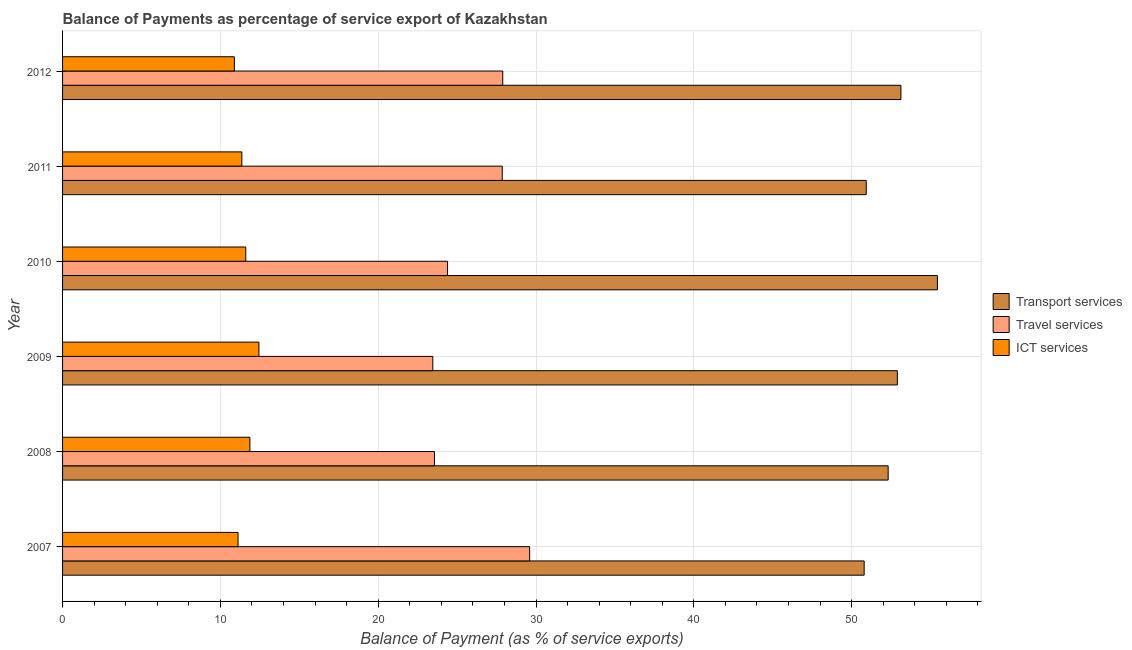Are the number of bars on each tick of the Y-axis equal?
Provide a short and direct response. Yes. How many bars are there on the 1st tick from the top?
Keep it short and to the point. 3. How many bars are there on the 2nd tick from the bottom?
Your response must be concise. 3. In how many cases, is the number of bars for a given year not equal to the number of legend labels?
Your answer should be very brief. 0. What is the balance of payment of ict services in 2008?
Your response must be concise. 11.87. Across all years, what is the maximum balance of payment of transport services?
Give a very brief answer. 55.44. Across all years, what is the minimum balance of payment of ict services?
Provide a short and direct response. 10.89. In which year was the balance of payment of travel services minimum?
Your response must be concise. 2009. What is the total balance of payment of ict services in the graph?
Your answer should be compact. 69.29. What is the difference between the balance of payment of travel services in 2007 and that in 2010?
Keep it short and to the point. 5.2. What is the difference between the balance of payment of ict services in 2007 and the balance of payment of travel services in 2011?
Provide a short and direct response. -16.74. What is the average balance of payment of transport services per year?
Your response must be concise. 52.58. In the year 2012, what is the difference between the balance of payment of travel services and balance of payment of ict services?
Provide a short and direct response. 17.01. Is the difference between the balance of payment of travel services in 2010 and 2012 greater than the difference between the balance of payment of transport services in 2010 and 2012?
Make the answer very short. No. What is the difference between the highest and the second highest balance of payment of travel services?
Offer a very short reply. 1.7. What is the difference between the highest and the lowest balance of payment of transport services?
Give a very brief answer. 4.64. In how many years, is the balance of payment of ict services greater than the average balance of payment of ict services taken over all years?
Offer a very short reply. 3. What does the 2nd bar from the top in 2008 represents?
Provide a short and direct response. Travel services. What does the 1st bar from the bottom in 2007 represents?
Offer a very short reply. Transport services. Are all the bars in the graph horizontal?
Ensure brevity in your answer.  Yes. Are the values on the major ticks of X-axis written in scientific E-notation?
Provide a succinct answer. No. Where does the legend appear in the graph?
Offer a terse response. Center right. How many legend labels are there?
Your response must be concise. 3. How are the legend labels stacked?
Keep it short and to the point. Vertical. What is the title of the graph?
Provide a short and direct response. Balance of Payments as percentage of service export of Kazakhstan. What is the label or title of the X-axis?
Offer a very short reply. Balance of Payment (as % of service exports). What is the label or title of the Y-axis?
Make the answer very short. Year. What is the Balance of Payment (as % of service exports) of Transport services in 2007?
Keep it short and to the point. 50.8. What is the Balance of Payment (as % of service exports) of Travel services in 2007?
Keep it short and to the point. 29.6. What is the Balance of Payment (as % of service exports) of ICT services in 2007?
Offer a very short reply. 11.12. What is the Balance of Payment (as % of service exports) in Transport services in 2008?
Make the answer very short. 52.32. What is the Balance of Payment (as % of service exports) in Travel services in 2008?
Your answer should be very brief. 23.57. What is the Balance of Payment (as % of service exports) in ICT services in 2008?
Offer a terse response. 11.87. What is the Balance of Payment (as % of service exports) in Transport services in 2009?
Provide a succinct answer. 52.9. What is the Balance of Payment (as % of service exports) of Travel services in 2009?
Your answer should be very brief. 23.46. What is the Balance of Payment (as % of service exports) of ICT services in 2009?
Make the answer very short. 12.44. What is the Balance of Payment (as % of service exports) in Transport services in 2010?
Ensure brevity in your answer.  55.44. What is the Balance of Payment (as % of service exports) in Travel services in 2010?
Offer a terse response. 24.39. What is the Balance of Payment (as % of service exports) of ICT services in 2010?
Your response must be concise. 11.61. What is the Balance of Payment (as % of service exports) in Transport services in 2011?
Provide a short and direct response. 50.93. What is the Balance of Payment (as % of service exports) in Travel services in 2011?
Provide a short and direct response. 27.86. What is the Balance of Payment (as % of service exports) in ICT services in 2011?
Provide a succinct answer. 11.36. What is the Balance of Payment (as % of service exports) of Transport services in 2012?
Provide a short and direct response. 53.12. What is the Balance of Payment (as % of service exports) of Travel services in 2012?
Provide a succinct answer. 27.89. What is the Balance of Payment (as % of service exports) of ICT services in 2012?
Offer a terse response. 10.89. Across all years, what is the maximum Balance of Payment (as % of service exports) of Transport services?
Give a very brief answer. 55.44. Across all years, what is the maximum Balance of Payment (as % of service exports) of Travel services?
Your answer should be compact. 29.6. Across all years, what is the maximum Balance of Payment (as % of service exports) in ICT services?
Your answer should be very brief. 12.44. Across all years, what is the minimum Balance of Payment (as % of service exports) in Transport services?
Make the answer very short. 50.8. Across all years, what is the minimum Balance of Payment (as % of service exports) in Travel services?
Your answer should be compact. 23.46. Across all years, what is the minimum Balance of Payment (as % of service exports) in ICT services?
Your answer should be compact. 10.89. What is the total Balance of Payment (as % of service exports) in Transport services in the graph?
Provide a short and direct response. 315.49. What is the total Balance of Payment (as % of service exports) in Travel services in the graph?
Provide a short and direct response. 156.77. What is the total Balance of Payment (as % of service exports) in ICT services in the graph?
Give a very brief answer. 69.29. What is the difference between the Balance of Payment (as % of service exports) of Transport services in 2007 and that in 2008?
Your response must be concise. -1.52. What is the difference between the Balance of Payment (as % of service exports) in Travel services in 2007 and that in 2008?
Give a very brief answer. 6.03. What is the difference between the Balance of Payment (as % of service exports) in ICT services in 2007 and that in 2008?
Your response must be concise. -0.75. What is the difference between the Balance of Payment (as % of service exports) of Transport services in 2007 and that in 2009?
Make the answer very short. -2.1. What is the difference between the Balance of Payment (as % of service exports) of Travel services in 2007 and that in 2009?
Provide a succinct answer. 6.14. What is the difference between the Balance of Payment (as % of service exports) in ICT services in 2007 and that in 2009?
Keep it short and to the point. -1.32. What is the difference between the Balance of Payment (as % of service exports) of Transport services in 2007 and that in 2010?
Your answer should be compact. -4.64. What is the difference between the Balance of Payment (as % of service exports) of Travel services in 2007 and that in 2010?
Offer a terse response. 5.2. What is the difference between the Balance of Payment (as % of service exports) in ICT services in 2007 and that in 2010?
Make the answer very short. -0.49. What is the difference between the Balance of Payment (as % of service exports) of Transport services in 2007 and that in 2011?
Give a very brief answer. -0.13. What is the difference between the Balance of Payment (as % of service exports) in Travel services in 2007 and that in 2011?
Make the answer very short. 1.74. What is the difference between the Balance of Payment (as % of service exports) of ICT services in 2007 and that in 2011?
Ensure brevity in your answer.  -0.24. What is the difference between the Balance of Payment (as % of service exports) in Transport services in 2007 and that in 2012?
Ensure brevity in your answer.  -2.33. What is the difference between the Balance of Payment (as % of service exports) in Travel services in 2007 and that in 2012?
Give a very brief answer. 1.7. What is the difference between the Balance of Payment (as % of service exports) of ICT services in 2007 and that in 2012?
Keep it short and to the point. 0.23. What is the difference between the Balance of Payment (as % of service exports) of Transport services in 2008 and that in 2009?
Provide a short and direct response. -0.58. What is the difference between the Balance of Payment (as % of service exports) of Travel services in 2008 and that in 2009?
Your answer should be compact. 0.11. What is the difference between the Balance of Payment (as % of service exports) of ICT services in 2008 and that in 2009?
Give a very brief answer. -0.57. What is the difference between the Balance of Payment (as % of service exports) of Transport services in 2008 and that in 2010?
Your answer should be very brief. -3.12. What is the difference between the Balance of Payment (as % of service exports) in Travel services in 2008 and that in 2010?
Give a very brief answer. -0.83. What is the difference between the Balance of Payment (as % of service exports) of ICT services in 2008 and that in 2010?
Your response must be concise. 0.26. What is the difference between the Balance of Payment (as % of service exports) of Transport services in 2008 and that in 2011?
Offer a terse response. 1.39. What is the difference between the Balance of Payment (as % of service exports) of Travel services in 2008 and that in 2011?
Provide a short and direct response. -4.29. What is the difference between the Balance of Payment (as % of service exports) of ICT services in 2008 and that in 2011?
Your response must be concise. 0.51. What is the difference between the Balance of Payment (as % of service exports) of Transport services in 2008 and that in 2012?
Make the answer very short. -0.81. What is the difference between the Balance of Payment (as % of service exports) of Travel services in 2008 and that in 2012?
Your answer should be very brief. -4.33. What is the difference between the Balance of Payment (as % of service exports) in ICT services in 2008 and that in 2012?
Offer a very short reply. 0.98. What is the difference between the Balance of Payment (as % of service exports) in Transport services in 2009 and that in 2010?
Your answer should be very brief. -2.54. What is the difference between the Balance of Payment (as % of service exports) in Travel services in 2009 and that in 2010?
Your response must be concise. -0.93. What is the difference between the Balance of Payment (as % of service exports) in ICT services in 2009 and that in 2010?
Keep it short and to the point. 0.83. What is the difference between the Balance of Payment (as % of service exports) of Transport services in 2009 and that in 2011?
Give a very brief answer. 1.97. What is the difference between the Balance of Payment (as % of service exports) of Travel services in 2009 and that in 2011?
Give a very brief answer. -4.4. What is the difference between the Balance of Payment (as % of service exports) of ICT services in 2009 and that in 2011?
Give a very brief answer. 1.08. What is the difference between the Balance of Payment (as % of service exports) in Transport services in 2009 and that in 2012?
Make the answer very short. -0.23. What is the difference between the Balance of Payment (as % of service exports) in Travel services in 2009 and that in 2012?
Provide a short and direct response. -4.43. What is the difference between the Balance of Payment (as % of service exports) of ICT services in 2009 and that in 2012?
Your answer should be compact. 1.56. What is the difference between the Balance of Payment (as % of service exports) of Transport services in 2010 and that in 2011?
Provide a succinct answer. 4.51. What is the difference between the Balance of Payment (as % of service exports) of Travel services in 2010 and that in 2011?
Provide a succinct answer. -3.47. What is the difference between the Balance of Payment (as % of service exports) in ICT services in 2010 and that in 2011?
Your answer should be very brief. 0.25. What is the difference between the Balance of Payment (as % of service exports) of Transport services in 2010 and that in 2012?
Your answer should be compact. 2.31. What is the difference between the Balance of Payment (as % of service exports) in Travel services in 2010 and that in 2012?
Provide a short and direct response. -3.5. What is the difference between the Balance of Payment (as % of service exports) of ICT services in 2010 and that in 2012?
Ensure brevity in your answer.  0.72. What is the difference between the Balance of Payment (as % of service exports) of Transport services in 2011 and that in 2012?
Give a very brief answer. -2.2. What is the difference between the Balance of Payment (as % of service exports) in Travel services in 2011 and that in 2012?
Your answer should be very brief. -0.03. What is the difference between the Balance of Payment (as % of service exports) in ICT services in 2011 and that in 2012?
Your answer should be very brief. 0.47. What is the difference between the Balance of Payment (as % of service exports) in Transport services in 2007 and the Balance of Payment (as % of service exports) in Travel services in 2008?
Keep it short and to the point. 27.23. What is the difference between the Balance of Payment (as % of service exports) of Transport services in 2007 and the Balance of Payment (as % of service exports) of ICT services in 2008?
Offer a terse response. 38.93. What is the difference between the Balance of Payment (as % of service exports) in Travel services in 2007 and the Balance of Payment (as % of service exports) in ICT services in 2008?
Give a very brief answer. 17.73. What is the difference between the Balance of Payment (as % of service exports) in Transport services in 2007 and the Balance of Payment (as % of service exports) in Travel services in 2009?
Your answer should be compact. 27.33. What is the difference between the Balance of Payment (as % of service exports) of Transport services in 2007 and the Balance of Payment (as % of service exports) of ICT services in 2009?
Provide a short and direct response. 38.35. What is the difference between the Balance of Payment (as % of service exports) of Travel services in 2007 and the Balance of Payment (as % of service exports) of ICT services in 2009?
Give a very brief answer. 17.15. What is the difference between the Balance of Payment (as % of service exports) of Transport services in 2007 and the Balance of Payment (as % of service exports) of Travel services in 2010?
Make the answer very short. 26.4. What is the difference between the Balance of Payment (as % of service exports) in Transport services in 2007 and the Balance of Payment (as % of service exports) in ICT services in 2010?
Your answer should be compact. 39.19. What is the difference between the Balance of Payment (as % of service exports) in Travel services in 2007 and the Balance of Payment (as % of service exports) in ICT services in 2010?
Offer a terse response. 17.99. What is the difference between the Balance of Payment (as % of service exports) in Transport services in 2007 and the Balance of Payment (as % of service exports) in Travel services in 2011?
Offer a very short reply. 22.93. What is the difference between the Balance of Payment (as % of service exports) of Transport services in 2007 and the Balance of Payment (as % of service exports) of ICT services in 2011?
Give a very brief answer. 39.43. What is the difference between the Balance of Payment (as % of service exports) of Travel services in 2007 and the Balance of Payment (as % of service exports) of ICT services in 2011?
Provide a succinct answer. 18.24. What is the difference between the Balance of Payment (as % of service exports) in Transport services in 2007 and the Balance of Payment (as % of service exports) in Travel services in 2012?
Your answer should be very brief. 22.9. What is the difference between the Balance of Payment (as % of service exports) in Transport services in 2007 and the Balance of Payment (as % of service exports) in ICT services in 2012?
Your answer should be compact. 39.91. What is the difference between the Balance of Payment (as % of service exports) of Travel services in 2007 and the Balance of Payment (as % of service exports) of ICT services in 2012?
Ensure brevity in your answer.  18.71. What is the difference between the Balance of Payment (as % of service exports) in Transport services in 2008 and the Balance of Payment (as % of service exports) in Travel services in 2009?
Provide a short and direct response. 28.85. What is the difference between the Balance of Payment (as % of service exports) of Transport services in 2008 and the Balance of Payment (as % of service exports) of ICT services in 2009?
Keep it short and to the point. 39.87. What is the difference between the Balance of Payment (as % of service exports) of Travel services in 2008 and the Balance of Payment (as % of service exports) of ICT services in 2009?
Give a very brief answer. 11.12. What is the difference between the Balance of Payment (as % of service exports) in Transport services in 2008 and the Balance of Payment (as % of service exports) in Travel services in 2010?
Offer a terse response. 27.92. What is the difference between the Balance of Payment (as % of service exports) in Transport services in 2008 and the Balance of Payment (as % of service exports) in ICT services in 2010?
Your response must be concise. 40.71. What is the difference between the Balance of Payment (as % of service exports) of Travel services in 2008 and the Balance of Payment (as % of service exports) of ICT services in 2010?
Your answer should be very brief. 11.96. What is the difference between the Balance of Payment (as % of service exports) in Transport services in 2008 and the Balance of Payment (as % of service exports) in Travel services in 2011?
Provide a succinct answer. 24.45. What is the difference between the Balance of Payment (as % of service exports) of Transport services in 2008 and the Balance of Payment (as % of service exports) of ICT services in 2011?
Make the answer very short. 40.95. What is the difference between the Balance of Payment (as % of service exports) of Travel services in 2008 and the Balance of Payment (as % of service exports) of ICT services in 2011?
Offer a terse response. 12.21. What is the difference between the Balance of Payment (as % of service exports) in Transport services in 2008 and the Balance of Payment (as % of service exports) in Travel services in 2012?
Your answer should be very brief. 24.42. What is the difference between the Balance of Payment (as % of service exports) of Transport services in 2008 and the Balance of Payment (as % of service exports) of ICT services in 2012?
Keep it short and to the point. 41.43. What is the difference between the Balance of Payment (as % of service exports) of Travel services in 2008 and the Balance of Payment (as % of service exports) of ICT services in 2012?
Your answer should be compact. 12.68. What is the difference between the Balance of Payment (as % of service exports) in Transport services in 2009 and the Balance of Payment (as % of service exports) in Travel services in 2010?
Your answer should be very brief. 28.5. What is the difference between the Balance of Payment (as % of service exports) in Transport services in 2009 and the Balance of Payment (as % of service exports) in ICT services in 2010?
Provide a succinct answer. 41.29. What is the difference between the Balance of Payment (as % of service exports) in Travel services in 2009 and the Balance of Payment (as % of service exports) in ICT services in 2010?
Give a very brief answer. 11.85. What is the difference between the Balance of Payment (as % of service exports) of Transport services in 2009 and the Balance of Payment (as % of service exports) of Travel services in 2011?
Ensure brevity in your answer.  25.04. What is the difference between the Balance of Payment (as % of service exports) of Transport services in 2009 and the Balance of Payment (as % of service exports) of ICT services in 2011?
Keep it short and to the point. 41.54. What is the difference between the Balance of Payment (as % of service exports) of Travel services in 2009 and the Balance of Payment (as % of service exports) of ICT services in 2011?
Provide a succinct answer. 12.1. What is the difference between the Balance of Payment (as % of service exports) of Transport services in 2009 and the Balance of Payment (as % of service exports) of Travel services in 2012?
Your response must be concise. 25. What is the difference between the Balance of Payment (as % of service exports) of Transport services in 2009 and the Balance of Payment (as % of service exports) of ICT services in 2012?
Provide a succinct answer. 42.01. What is the difference between the Balance of Payment (as % of service exports) in Travel services in 2009 and the Balance of Payment (as % of service exports) in ICT services in 2012?
Offer a very short reply. 12.57. What is the difference between the Balance of Payment (as % of service exports) of Transport services in 2010 and the Balance of Payment (as % of service exports) of Travel services in 2011?
Ensure brevity in your answer.  27.58. What is the difference between the Balance of Payment (as % of service exports) of Transport services in 2010 and the Balance of Payment (as % of service exports) of ICT services in 2011?
Offer a terse response. 44.08. What is the difference between the Balance of Payment (as % of service exports) in Travel services in 2010 and the Balance of Payment (as % of service exports) in ICT services in 2011?
Your answer should be compact. 13.03. What is the difference between the Balance of Payment (as % of service exports) of Transport services in 2010 and the Balance of Payment (as % of service exports) of Travel services in 2012?
Make the answer very short. 27.54. What is the difference between the Balance of Payment (as % of service exports) of Transport services in 2010 and the Balance of Payment (as % of service exports) of ICT services in 2012?
Offer a terse response. 44.55. What is the difference between the Balance of Payment (as % of service exports) in Travel services in 2010 and the Balance of Payment (as % of service exports) in ICT services in 2012?
Provide a short and direct response. 13.51. What is the difference between the Balance of Payment (as % of service exports) in Transport services in 2011 and the Balance of Payment (as % of service exports) in Travel services in 2012?
Ensure brevity in your answer.  23.03. What is the difference between the Balance of Payment (as % of service exports) of Transport services in 2011 and the Balance of Payment (as % of service exports) of ICT services in 2012?
Make the answer very short. 40.04. What is the difference between the Balance of Payment (as % of service exports) of Travel services in 2011 and the Balance of Payment (as % of service exports) of ICT services in 2012?
Make the answer very short. 16.97. What is the average Balance of Payment (as % of service exports) of Transport services per year?
Keep it short and to the point. 52.58. What is the average Balance of Payment (as % of service exports) of Travel services per year?
Ensure brevity in your answer.  26.13. What is the average Balance of Payment (as % of service exports) of ICT services per year?
Keep it short and to the point. 11.55. In the year 2007, what is the difference between the Balance of Payment (as % of service exports) of Transport services and Balance of Payment (as % of service exports) of Travel services?
Keep it short and to the point. 21.2. In the year 2007, what is the difference between the Balance of Payment (as % of service exports) in Transport services and Balance of Payment (as % of service exports) in ICT services?
Your answer should be very brief. 39.68. In the year 2007, what is the difference between the Balance of Payment (as % of service exports) of Travel services and Balance of Payment (as % of service exports) of ICT services?
Provide a short and direct response. 18.48. In the year 2008, what is the difference between the Balance of Payment (as % of service exports) of Transport services and Balance of Payment (as % of service exports) of Travel services?
Provide a succinct answer. 28.75. In the year 2008, what is the difference between the Balance of Payment (as % of service exports) of Transport services and Balance of Payment (as % of service exports) of ICT services?
Ensure brevity in your answer.  40.45. In the year 2008, what is the difference between the Balance of Payment (as % of service exports) in Travel services and Balance of Payment (as % of service exports) in ICT services?
Ensure brevity in your answer.  11.7. In the year 2009, what is the difference between the Balance of Payment (as % of service exports) of Transport services and Balance of Payment (as % of service exports) of Travel services?
Offer a terse response. 29.44. In the year 2009, what is the difference between the Balance of Payment (as % of service exports) of Transport services and Balance of Payment (as % of service exports) of ICT services?
Provide a succinct answer. 40.45. In the year 2009, what is the difference between the Balance of Payment (as % of service exports) of Travel services and Balance of Payment (as % of service exports) of ICT services?
Provide a short and direct response. 11.02. In the year 2010, what is the difference between the Balance of Payment (as % of service exports) of Transport services and Balance of Payment (as % of service exports) of Travel services?
Give a very brief answer. 31.04. In the year 2010, what is the difference between the Balance of Payment (as % of service exports) in Transport services and Balance of Payment (as % of service exports) in ICT services?
Ensure brevity in your answer.  43.83. In the year 2010, what is the difference between the Balance of Payment (as % of service exports) of Travel services and Balance of Payment (as % of service exports) of ICT services?
Make the answer very short. 12.79. In the year 2011, what is the difference between the Balance of Payment (as % of service exports) of Transport services and Balance of Payment (as % of service exports) of Travel services?
Provide a short and direct response. 23.07. In the year 2011, what is the difference between the Balance of Payment (as % of service exports) of Transport services and Balance of Payment (as % of service exports) of ICT services?
Keep it short and to the point. 39.57. In the year 2011, what is the difference between the Balance of Payment (as % of service exports) of Travel services and Balance of Payment (as % of service exports) of ICT services?
Your response must be concise. 16.5. In the year 2012, what is the difference between the Balance of Payment (as % of service exports) in Transport services and Balance of Payment (as % of service exports) in Travel services?
Give a very brief answer. 25.23. In the year 2012, what is the difference between the Balance of Payment (as % of service exports) of Transport services and Balance of Payment (as % of service exports) of ICT services?
Your answer should be compact. 42.24. In the year 2012, what is the difference between the Balance of Payment (as % of service exports) in Travel services and Balance of Payment (as % of service exports) in ICT services?
Give a very brief answer. 17.01. What is the ratio of the Balance of Payment (as % of service exports) of Transport services in 2007 to that in 2008?
Offer a very short reply. 0.97. What is the ratio of the Balance of Payment (as % of service exports) of Travel services in 2007 to that in 2008?
Offer a terse response. 1.26. What is the ratio of the Balance of Payment (as % of service exports) in ICT services in 2007 to that in 2008?
Your answer should be very brief. 0.94. What is the ratio of the Balance of Payment (as % of service exports) of Transport services in 2007 to that in 2009?
Provide a succinct answer. 0.96. What is the ratio of the Balance of Payment (as % of service exports) of Travel services in 2007 to that in 2009?
Your answer should be very brief. 1.26. What is the ratio of the Balance of Payment (as % of service exports) in ICT services in 2007 to that in 2009?
Give a very brief answer. 0.89. What is the ratio of the Balance of Payment (as % of service exports) of Transport services in 2007 to that in 2010?
Offer a terse response. 0.92. What is the ratio of the Balance of Payment (as % of service exports) in Travel services in 2007 to that in 2010?
Make the answer very short. 1.21. What is the ratio of the Balance of Payment (as % of service exports) in ICT services in 2007 to that in 2010?
Provide a succinct answer. 0.96. What is the ratio of the Balance of Payment (as % of service exports) in Travel services in 2007 to that in 2011?
Your response must be concise. 1.06. What is the ratio of the Balance of Payment (as % of service exports) of ICT services in 2007 to that in 2011?
Keep it short and to the point. 0.98. What is the ratio of the Balance of Payment (as % of service exports) of Transport services in 2007 to that in 2012?
Ensure brevity in your answer.  0.96. What is the ratio of the Balance of Payment (as % of service exports) of Travel services in 2007 to that in 2012?
Make the answer very short. 1.06. What is the ratio of the Balance of Payment (as % of service exports) of ICT services in 2007 to that in 2012?
Keep it short and to the point. 1.02. What is the ratio of the Balance of Payment (as % of service exports) in ICT services in 2008 to that in 2009?
Offer a very short reply. 0.95. What is the ratio of the Balance of Payment (as % of service exports) of Transport services in 2008 to that in 2010?
Provide a short and direct response. 0.94. What is the ratio of the Balance of Payment (as % of service exports) in ICT services in 2008 to that in 2010?
Ensure brevity in your answer.  1.02. What is the ratio of the Balance of Payment (as % of service exports) of Transport services in 2008 to that in 2011?
Your answer should be compact. 1.03. What is the ratio of the Balance of Payment (as % of service exports) of Travel services in 2008 to that in 2011?
Your answer should be very brief. 0.85. What is the ratio of the Balance of Payment (as % of service exports) of ICT services in 2008 to that in 2011?
Provide a short and direct response. 1.04. What is the ratio of the Balance of Payment (as % of service exports) in Transport services in 2008 to that in 2012?
Make the answer very short. 0.98. What is the ratio of the Balance of Payment (as % of service exports) of Travel services in 2008 to that in 2012?
Provide a succinct answer. 0.84. What is the ratio of the Balance of Payment (as % of service exports) of ICT services in 2008 to that in 2012?
Your response must be concise. 1.09. What is the ratio of the Balance of Payment (as % of service exports) in Transport services in 2009 to that in 2010?
Your answer should be compact. 0.95. What is the ratio of the Balance of Payment (as % of service exports) of Travel services in 2009 to that in 2010?
Your response must be concise. 0.96. What is the ratio of the Balance of Payment (as % of service exports) of ICT services in 2009 to that in 2010?
Provide a succinct answer. 1.07. What is the ratio of the Balance of Payment (as % of service exports) of Transport services in 2009 to that in 2011?
Give a very brief answer. 1.04. What is the ratio of the Balance of Payment (as % of service exports) of Travel services in 2009 to that in 2011?
Your answer should be compact. 0.84. What is the ratio of the Balance of Payment (as % of service exports) in ICT services in 2009 to that in 2011?
Your answer should be very brief. 1.1. What is the ratio of the Balance of Payment (as % of service exports) in Travel services in 2009 to that in 2012?
Ensure brevity in your answer.  0.84. What is the ratio of the Balance of Payment (as % of service exports) of Transport services in 2010 to that in 2011?
Your response must be concise. 1.09. What is the ratio of the Balance of Payment (as % of service exports) in Travel services in 2010 to that in 2011?
Offer a very short reply. 0.88. What is the ratio of the Balance of Payment (as % of service exports) in ICT services in 2010 to that in 2011?
Your answer should be very brief. 1.02. What is the ratio of the Balance of Payment (as % of service exports) in Transport services in 2010 to that in 2012?
Keep it short and to the point. 1.04. What is the ratio of the Balance of Payment (as % of service exports) in Travel services in 2010 to that in 2012?
Give a very brief answer. 0.87. What is the ratio of the Balance of Payment (as % of service exports) in ICT services in 2010 to that in 2012?
Offer a terse response. 1.07. What is the ratio of the Balance of Payment (as % of service exports) of Transport services in 2011 to that in 2012?
Make the answer very short. 0.96. What is the ratio of the Balance of Payment (as % of service exports) in Travel services in 2011 to that in 2012?
Give a very brief answer. 1. What is the ratio of the Balance of Payment (as % of service exports) of ICT services in 2011 to that in 2012?
Provide a succinct answer. 1.04. What is the difference between the highest and the second highest Balance of Payment (as % of service exports) of Transport services?
Your answer should be compact. 2.31. What is the difference between the highest and the second highest Balance of Payment (as % of service exports) in Travel services?
Ensure brevity in your answer.  1.7. What is the difference between the highest and the second highest Balance of Payment (as % of service exports) of ICT services?
Provide a succinct answer. 0.57. What is the difference between the highest and the lowest Balance of Payment (as % of service exports) in Transport services?
Offer a very short reply. 4.64. What is the difference between the highest and the lowest Balance of Payment (as % of service exports) of Travel services?
Your answer should be compact. 6.14. What is the difference between the highest and the lowest Balance of Payment (as % of service exports) of ICT services?
Provide a short and direct response. 1.56. 